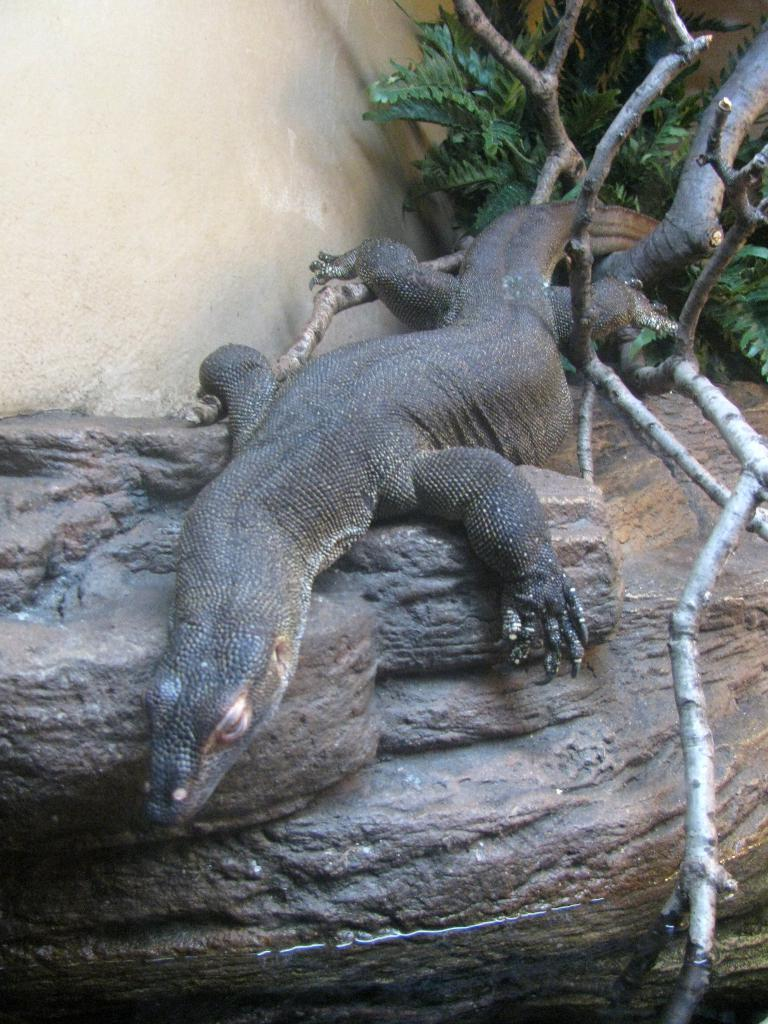What type of animal is in the image? There is a reptile in the image. Where is the reptile located? The reptile is on a rock. What can be seen in the background of the image? There are branches and leaves in the background of the image. What type of bun is the reptile holding in the image? There is no bun present in the image; it features a reptile on a rock with branches and leaves in the background. 